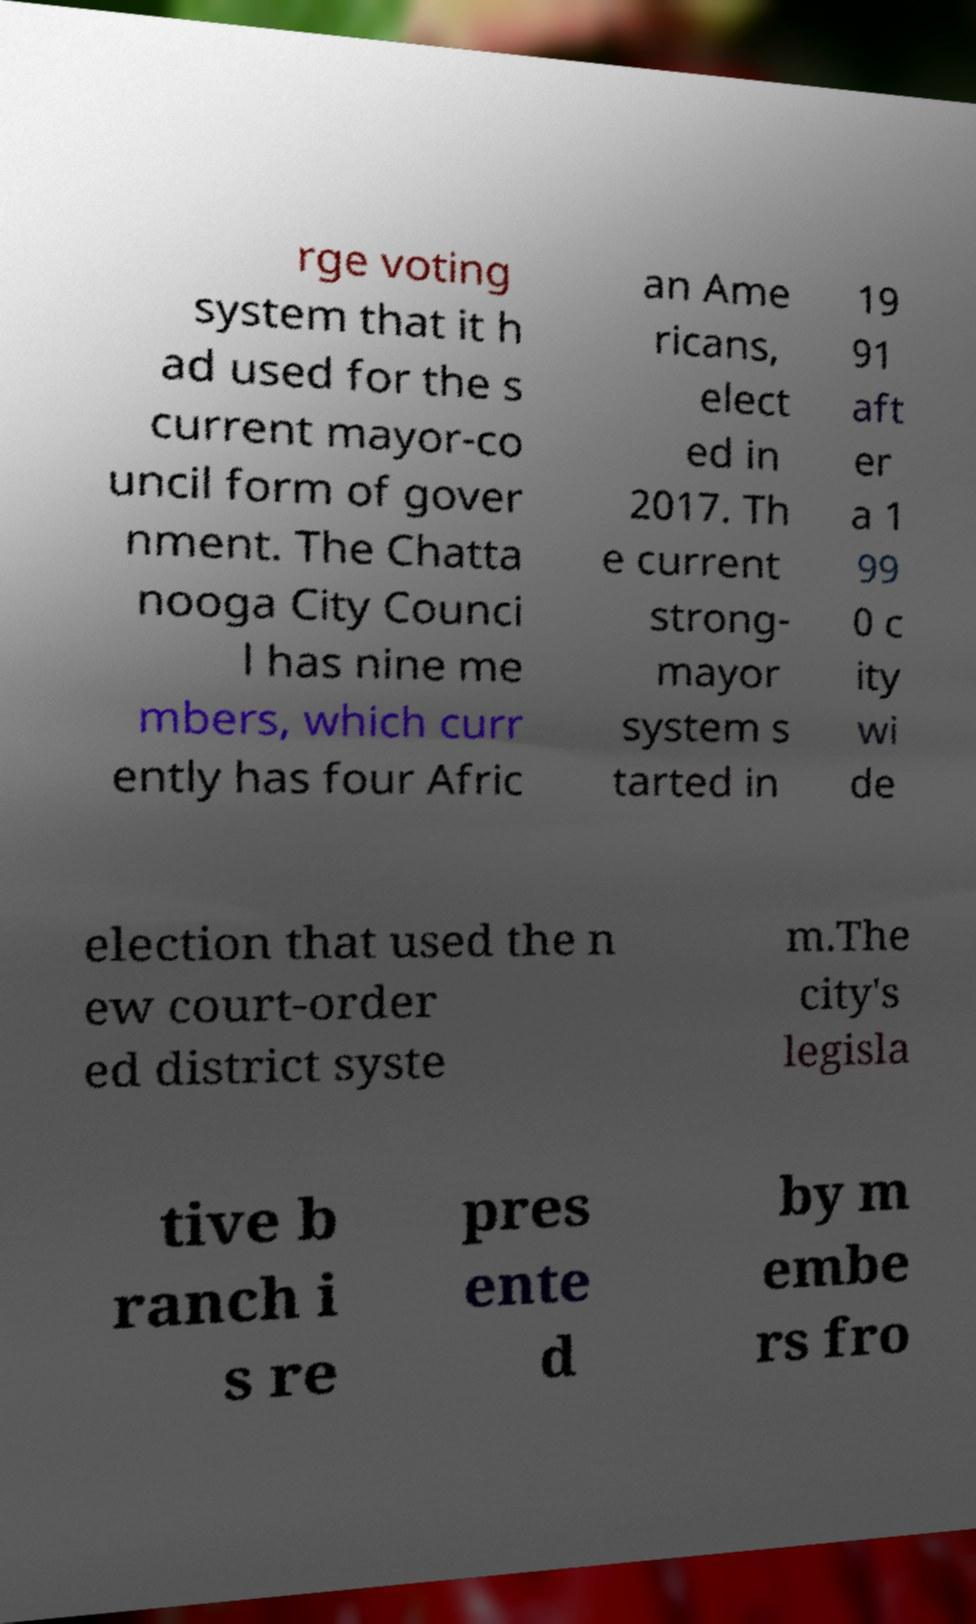What messages or text are displayed in this image? I need them in a readable, typed format. rge voting system that it h ad used for the s current mayor-co uncil form of gover nment. The Chatta nooga City Counci l has nine me mbers, which curr ently has four Afric an Ame ricans, elect ed in 2017. Th e current strong- mayor system s tarted in 19 91 aft er a 1 99 0 c ity wi de election that used the n ew court-order ed district syste m.The city's legisla tive b ranch i s re pres ente d by m embe rs fro 